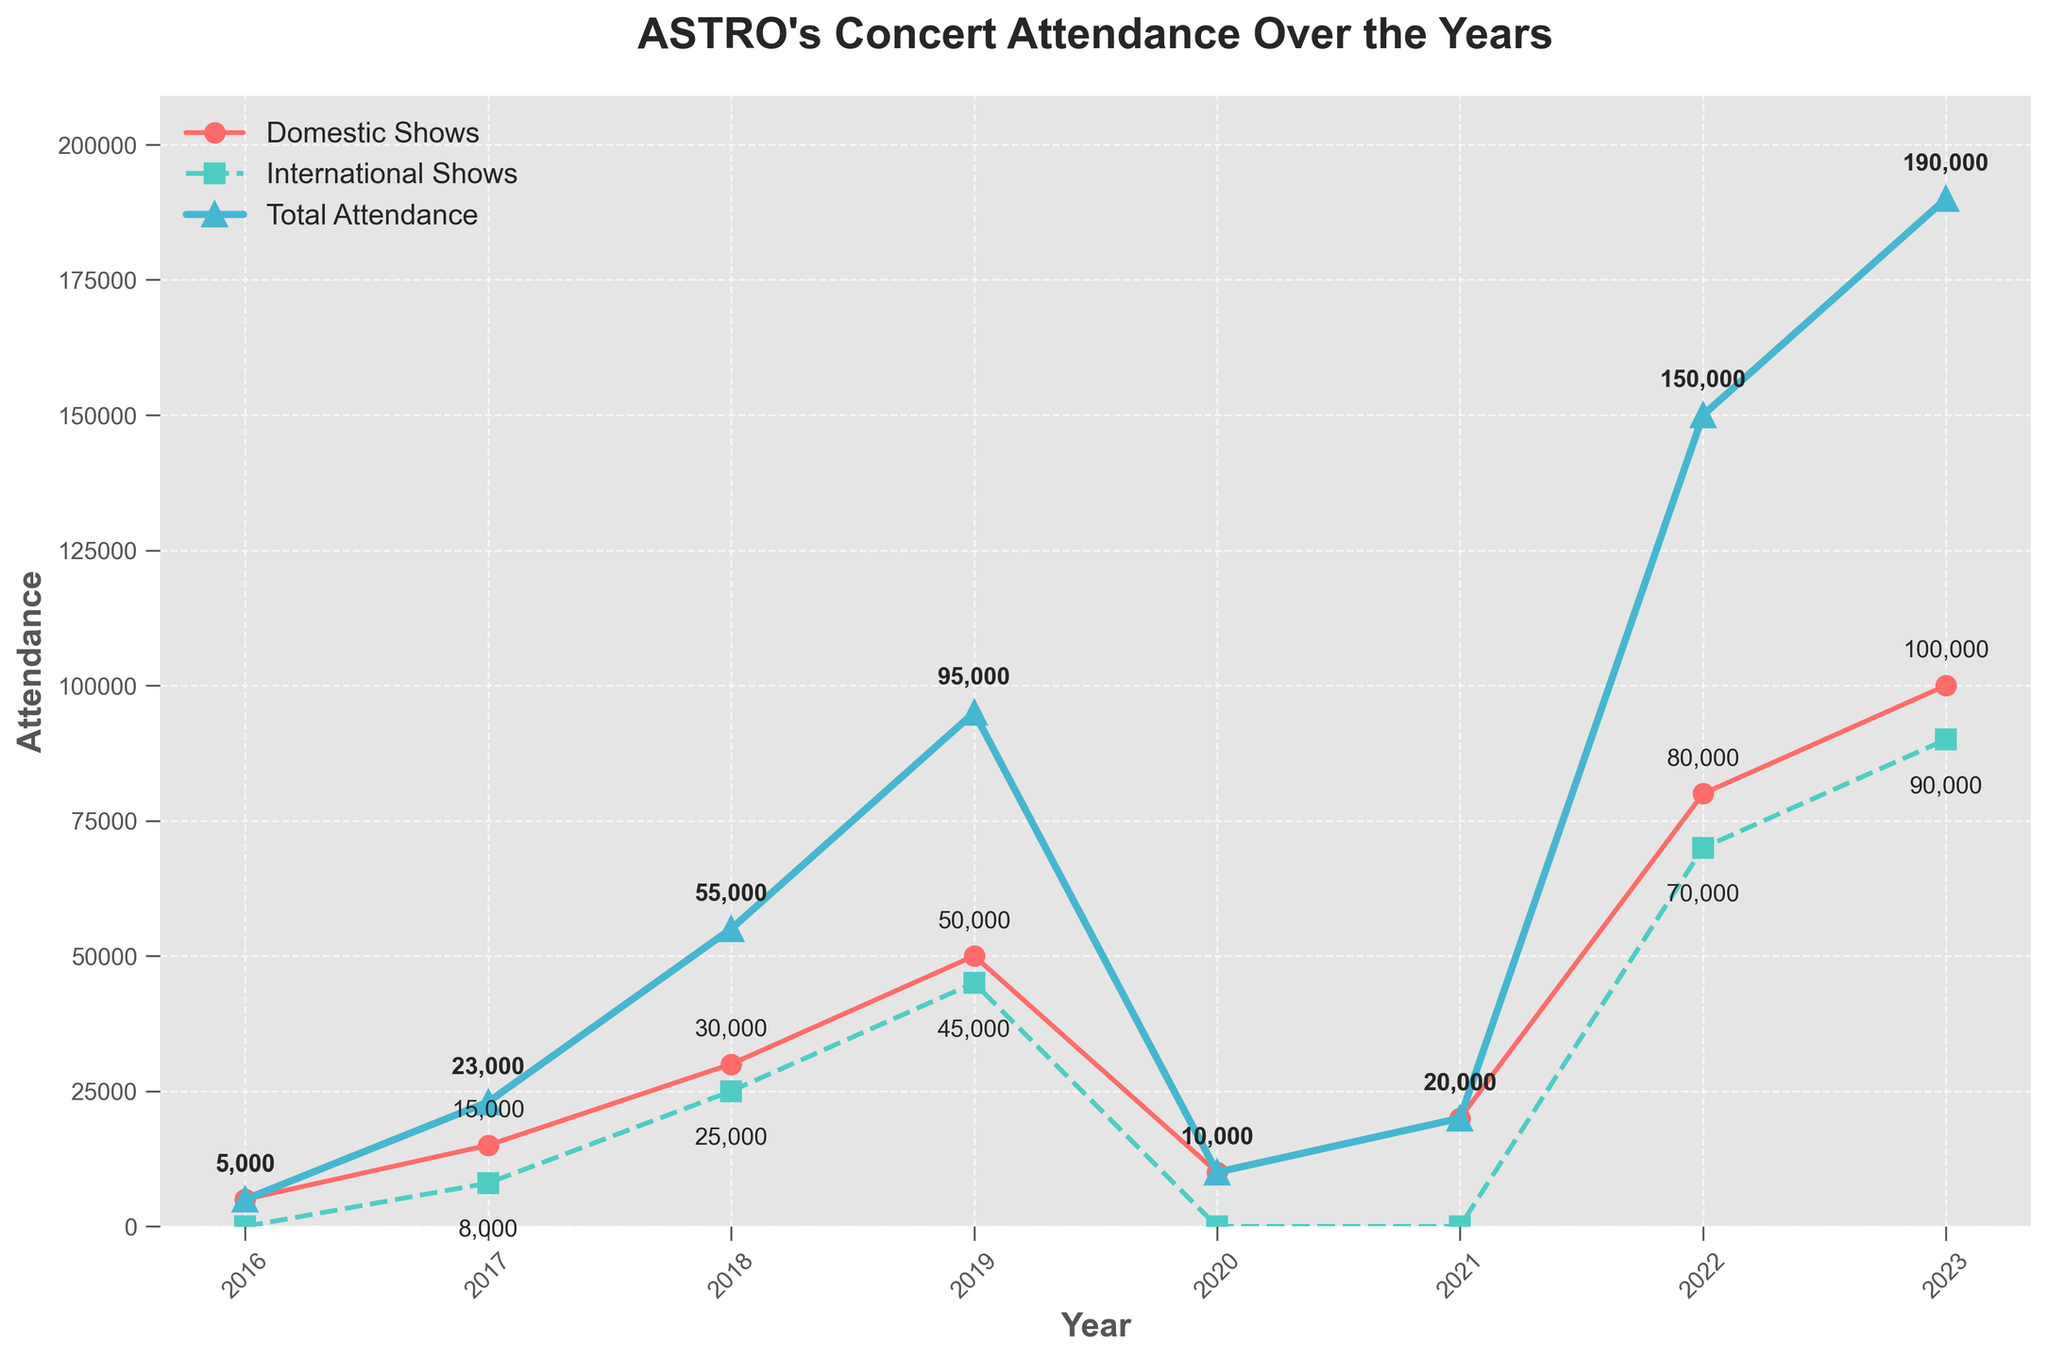What year had the highest total attendance? By looking at the plot, the highest point on the 'Total Attendance' line indicates the year with the highest total attendance. In this case, it is 2023.
Answer: 2023 What is the difference in total attendance between 2018 and 2019? Look at the 'Total Attendance' plot points for the years 2018 and 2019 (55000 and 95000, respectively). Subtract the 2018 value from the 2019 value: 95000 - 55000 = 40000.
Answer: 40000 Which year had the first international show for ASTRO? Refer to the 'International Shows' line, the first appearance or non-zero marker indicates the first year with international shows. This occurs in 2017.
Answer: 2017 How does the domestic show attendance in 2020 compare to the total attendance in the same year? Compare the 'Domestic Shows' and 'Total Attendance' values for 2020. Both are 10000, so they are equal.
Answer: They are equal What's the total sum of attendances for domestic shows across all the years on the chart? Sum the annual 'Domestic Shows' values: 5000 + 15000 + 30000 + 50000 + 10000 + 20000 + 80000 + 100000 = 310000.
Answer: 310000 During which year did international shows have the highest attendance? Identify the highest point on the 'International Shows' line, which occurs in 2023 at 90000.
Answer: 2023 What is the average attendance for international shows from 2017 to 2023? Calculate the sum of 'International Shows' values from 2017 to 2023 (8000 + 25000 + 45000 + 0 + 0 + 70000 + 90000 = 237000) and divide by the number of years (7). 237000 / 7 = 33857.14.
Answer: 33857.14 How much did domestic show attendance increase from 2017 to 2018? Compare 'Domestic Shows' values for 2017 and 2018 (15000 and 30000, respectively). Subtract 2017 from 2018: 30000 - 15000 = 15000.
Answer: 15000 In which year did domestic show attendance exceed international show attendance by the largest margin? Calculate the difference between 'Domestic Shows' and 'International Shows' for each year and identify the year with the maximum difference. The largest positive margin is in 2023 with a difference of 10000 (100000 - 90000).
Answer: 2023 What's the overall trend in total attendance from 2016 to 2023? The 'Total Attendance' line shows a general increasing trend, peaking in 2023, despite a drop in 2020.
Answer: Increasing with a peak in 2023 